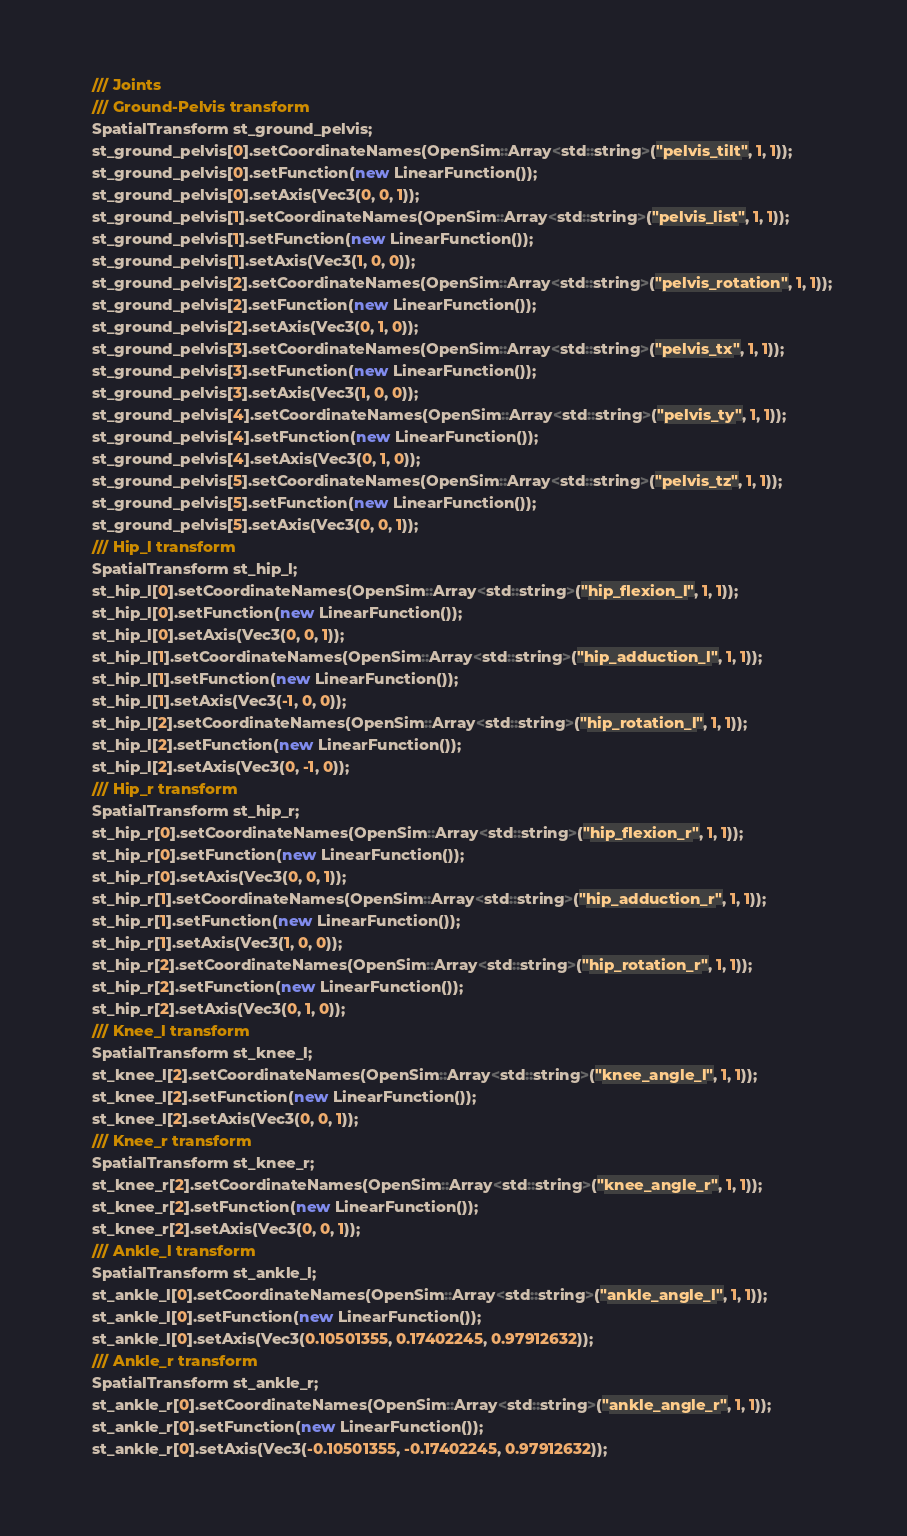Convert code to text. <code><loc_0><loc_0><loc_500><loc_500><_C++_>


	/// Joints
	/// Ground-Pelvis transform
	SpatialTransform st_ground_pelvis;
	st_ground_pelvis[0].setCoordinateNames(OpenSim::Array<std::string>("pelvis_tilt", 1, 1));
	st_ground_pelvis[0].setFunction(new LinearFunction());
	st_ground_pelvis[0].setAxis(Vec3(0, 0, 1));
	st_ground_pelvis[1].setCoordinateNames(OpenSim::Array<std::string>("pelvis_list", 1, 1));
	st_ground_pelvis[1].setFunction(new LinearFunction());
	st_ground_pelvis[1].setAxis(Vec3(1, 0, 0));
	st_ground_pelvis[2].setCoordinateNames(OpenSim::Array<std::string>("pelvis_rotation", 1, 1));
	st_ground_pelvis[2].setFunction(new LinearFunction());
	st_ground_pelvis[2].setAxis(Vec3(0, 1, 0));
	st_ground_pelvis[3].setCoordinateNames(OpenSim::Array<std::string>("pelvis_tx", 1, 1));
	st_ground_pelvis[3].setFunction(new LinearFunction());
	st_ground_pelvis[3].setAxis(Vec3(1, 0, 0));
	st_ground_pelvis[4].setCoordinateNames(OpenSim::Array<std::string>("pelvis_ty", 1, 1));
	st_ground_pelvis[4].setFunction(new LinearFunction());
	st_ground_pelvis[4].setAxis(Vec3(0, 1, 0));
	st_ground_pelvis[5].setCoordinateNames(OpenSim::Array<std::string>("pelvis_tz", 1, 1));
	st_ground_pelvis[5].setFunction(new LinearFunction());
	st_ground_pelvis[5].setAxis(Vec3(0, 0, 1));
	/// Hip_l transform
	SpatialTransform st_hip_l;
	st_hip_l[0].setCoordinateNames(OpenSim::Array<std::string>("hip_flexion_l", 1, 1));
	st_hip_l[0].setFunction(new LinearFunction());
	st_hip_l[0].setAxis(Vec3(0, 0, 1));
	st_hip_l[1].setCoordinateNames(OpenSim::Array<std::string>("hip_adduction_l", 1, 1));
	st_hip_l[1].setFunction(new LinearFunction());
	st_hip_l[1].setAxis(Vec3(-1, 0, 0));
	st_hip_l[2].setCoordinateNames(OpenSim::Array<std::string>("hip_rotation_l", 1, 1));
	st_hip_l[2].setFunction(new LinearFunction());
	st_hip_l[2].setAxis(Vec3(0, -1, 0));
	/// Hip_r transform
	SpatialTransform st_hip_r;
	st_hip_r[0].setCoordinateNames(OpenSim::Array<std::string>("hip_flexion_r", 1, 1));
	st_hip_r[0].setFunction(new LinearFunction());
	st_hip_r[0].setAxis(Vec3(0, 0, 1));
	st_hip_r[1].setCoordinateNames(OpenSim::Array<std::string>("hip_adduction_r", 1, 1));
	st_hip_r[1].setFunction(new LinearFunction());
	st_hip_r[1].setAxis(Vec3(1, 0, 0));
	st_hip_r[2].setCoordinateNames(OpenSim::Array<std::string>("hip_rotation_r", 1, 1));
	st_hip_r[2].setFunction(new LinearFunction());
	st_hip_r[2].setAxis(Vec3(0, 1, 0));
	/// Knee_l transform
	SpatialTransform st_knee_l;
	st_knee_l[2].setCoordinateNames(OpenSim::Array<std::string>("knee_angle_l", 1, 1));
	st_knee_l[2].setFunction(new LinearFunction());
	st_knee_l[2].setAxis(Vec3(0, 0, 1));
	/// Knee_r transform
	SpatialTransform st_knee_r;
	st_knee_r[2].setCoordinateNames(OpenSim::Array<std::string>("knee_angle_r", 1, 1));
	st_knee_r[2].setFunction(new LinearFunction());
	st_knee_r[2].setAxis(Vec3(0, 0, 1));
	/// Ankle_l transform
	SpatialTransform st_ankle_l;
	st_ankle_l[0].setCoordinateNames(OpenSim::Array<std::string>("ankle_angle_l", 1, 1));
	st_ankle_l[0].setFunction(new LinearFunction());
	st_ankle_l[0].setAxis(Vec3(0.10501355, 0.17402245, 0.97912632));
	/// Ankle_r transform
	SpatialTransform st_ankle_r;
	st_ankle_r[0].setCoordinateNames(OpenSim::Array<std::string>("ankle_angle_r", 1, 1));
	st_ankle_r[0].setFunction(new LinearFunction());
	st_ankle_r[0].setAxis(Vec3(-0.10501355, -0.17402245, 0.97912632));</code> 